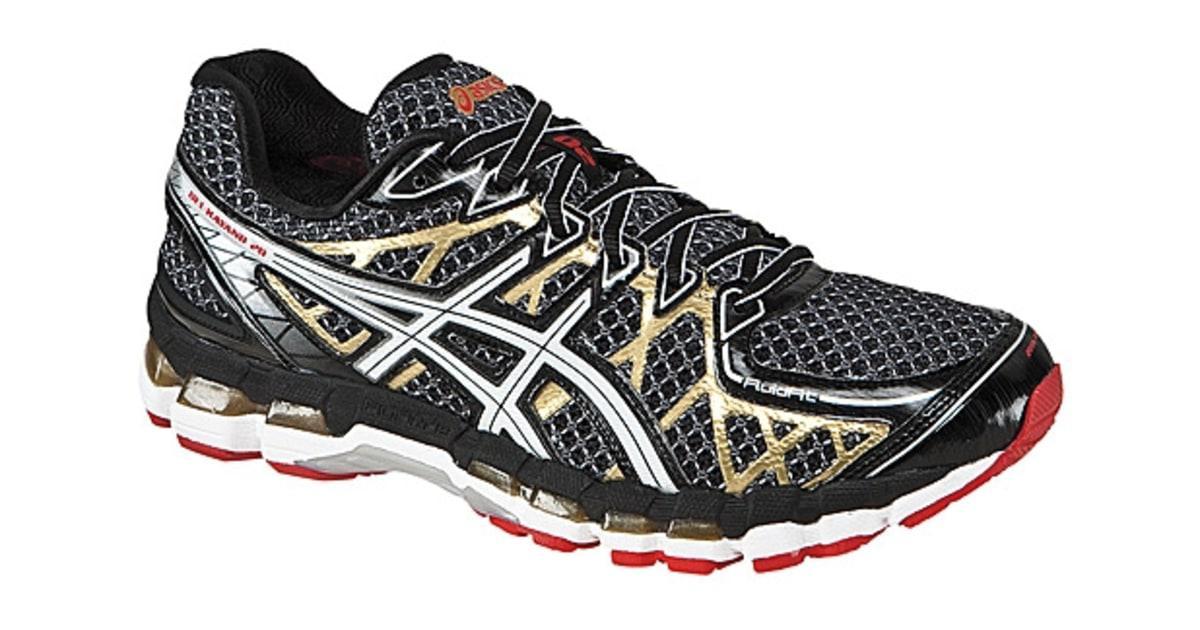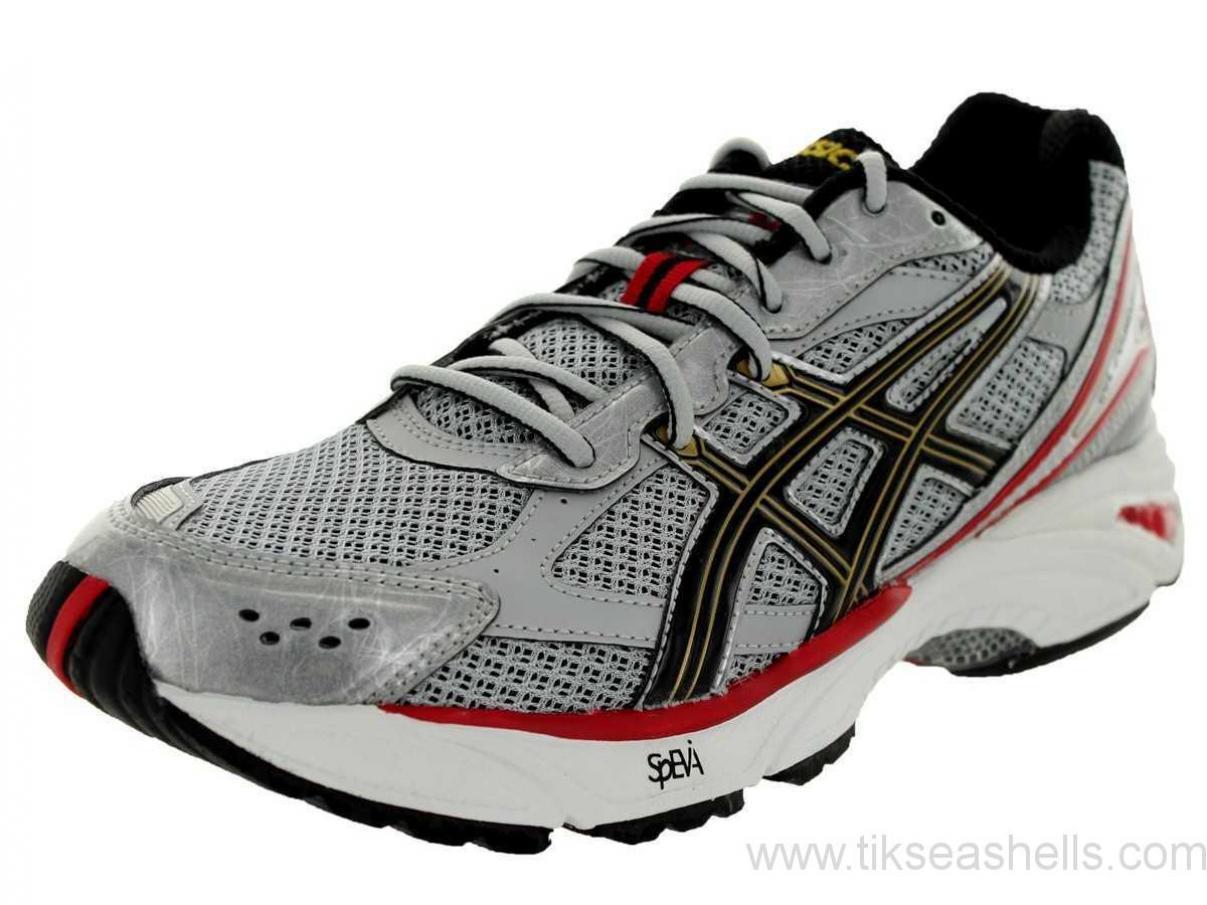The first image is the image on the left, the second image is the image on the right. For the images shown, is this caption "There is no more than one tennis shoe in the left image." true? Answer yes or no. Yes. The first image is the image on the left, the second image is the image on the right. Examine the images to the left and right. Is the description "At least one image shows a pair of shoes that lacks the color red." accurate? Answer yes or no. No. 